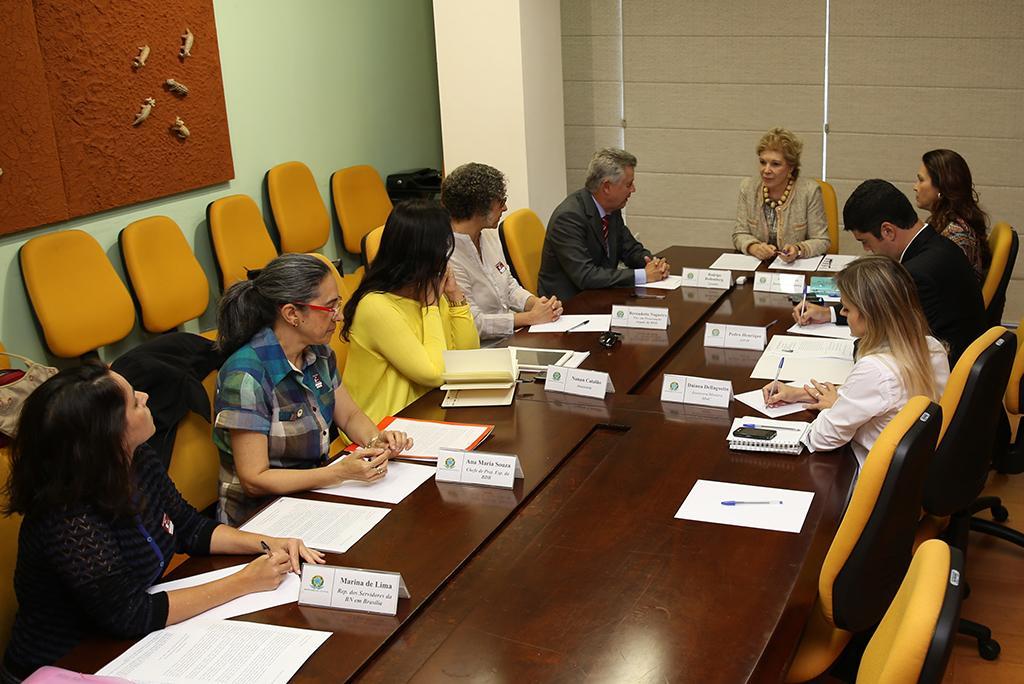Describe this image in one or two sentences. This is the picture of a room. In this image there are group of people sitting. There are papers and boards and there are devices on the table. On the left side of the image there are chairs and there is a board on the wall. At the back there is a pillar and there are window blinds. At the bottom there is a floor. 